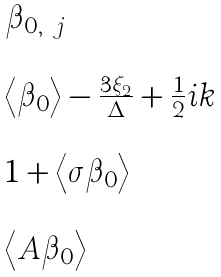Convert formula to latex. <formula><loc_0><loc_0><loc_500><loc_500>\begin{array} { l } \beta _ { 0 , \ j } \\ \\ \left \langle \beta _ { 0 } \right \rangle - \frac { 3 \xi _ { 2 } } \Delta + \frac { 1 } { 2 } i k \\ \\ 1 + \left \langle \sigma \beta _ { 0 } \right \rangle \\ \\ \left \langle A \beta _ { 0 } \right \rangle \end{array}</formula> 